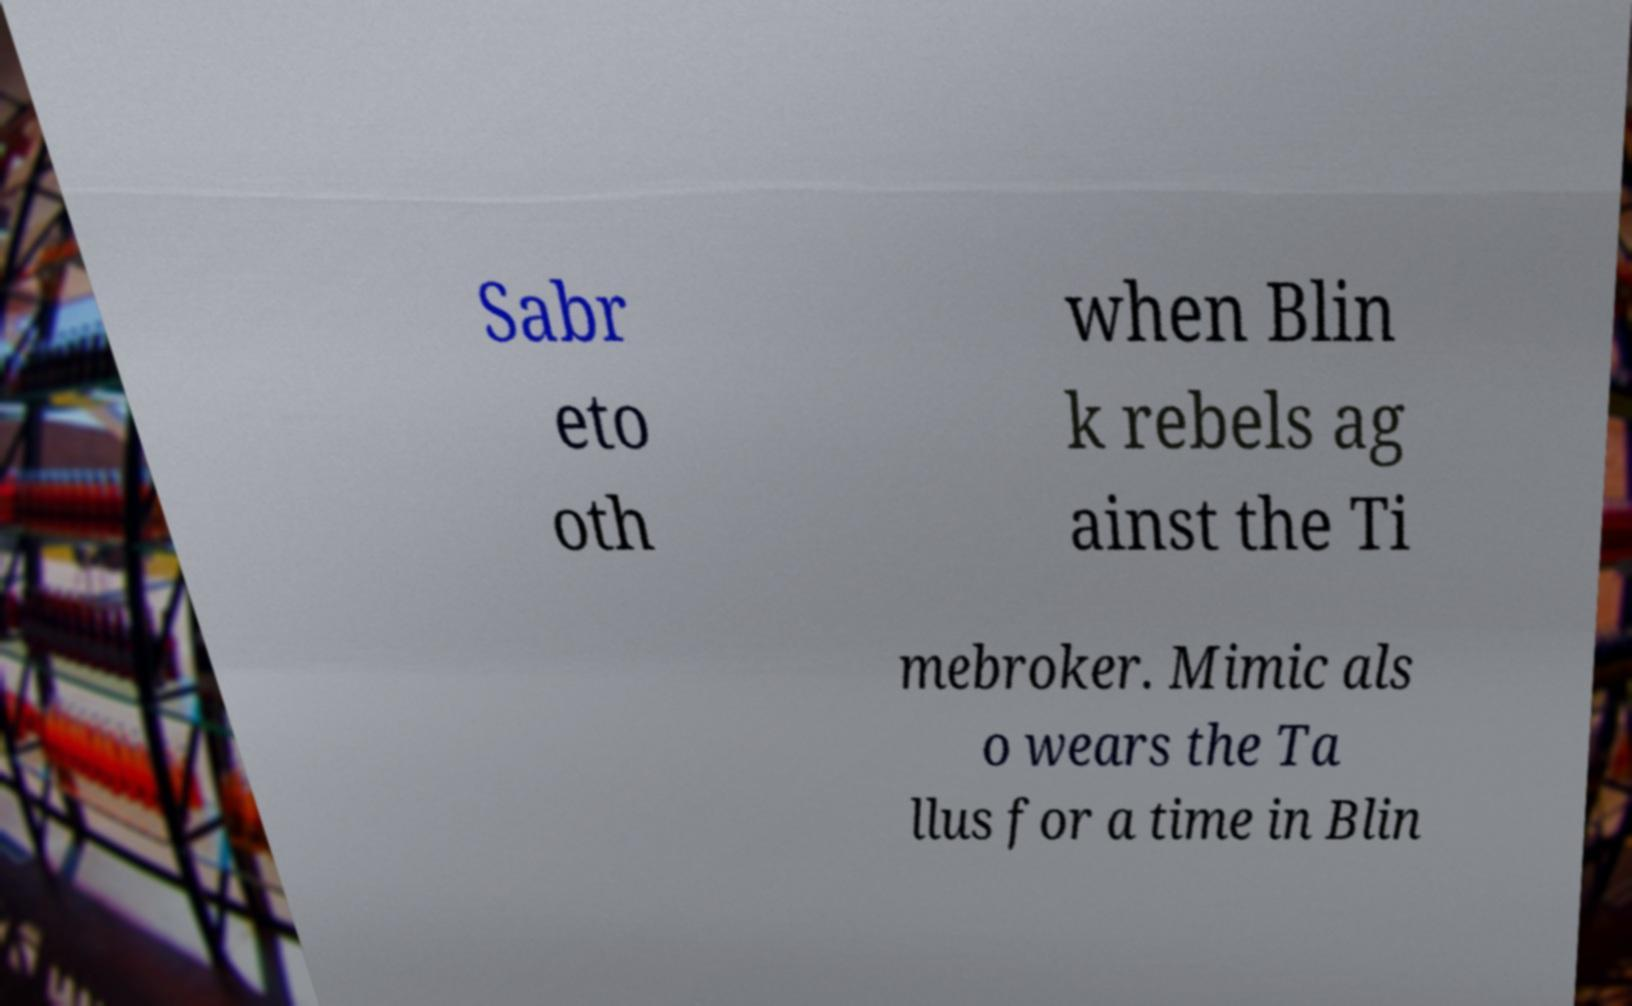Can you accurately transcribe the text from the provided image for me? Sabr eto oth when Blin k rebels ag ainst the Ti mebroker. Mimic als o wears the Ta llus for a time in Blin 